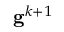Convert formula to latex. <formula><loc_0><loc_0><loc_500><loc_500>g ^ { k + 1 }</formula> 